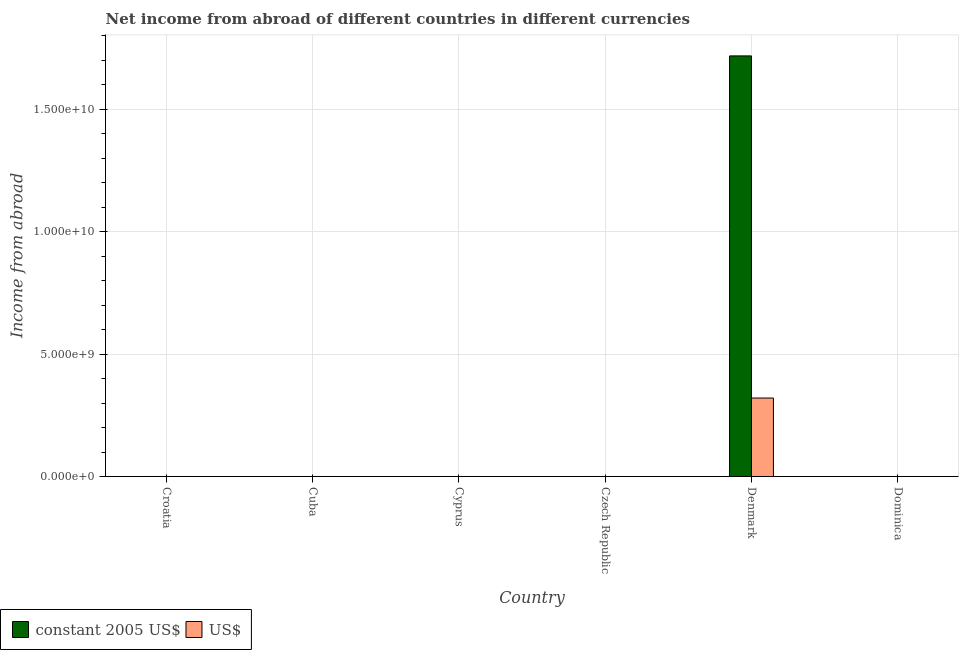What is the label of the 1st group of bars from the left?
Your answer should be compact. Croatia. What is the income from abroad in constant 2005 us$ in Denmark?
Ensure brevity in your answer.  1.72e+1. Across all countries, what is the maximum income from abroad in constant 2005 us$?
Your answer should be very brief. 1.72e+1. Across all countries, what is the minimum income from abroad in us$?
Give a very brief answer. 0. In which country was the income from abroad in constant 2005 us$ maximum?
Provide a short and direct response. Denmark. What is the total income from abroad in constant 2005 us$ in the graph?
Your response must be concise. 1.72e+1. What is the difference between the income from abroad in constant 2005 us$ in Denmark and the income from abroad in us$ in Croatia?
Provide a short and direct response. 1.72e+1. What is the average income from abroad in constant 2005 us$ per country?
Give a very brief answer. 2.86e+09. What is the difference between the income from abroad in us$ and income from abroad in constant 2005 us$ in Denmark?
Offer a very short reply. -1.40e+1. In how many countries, is the income from abroad in us$ greater than 7000000000 units?
Provide a short and direct response. 0. What is the difference between the highest and the lowest income from abroad in constant 2005 us$?
Provide a succinct answer. 1.72e+1. In how many countries, is the income from abroad in constant 2005 us$ greater than the average income from abroad in constant 2005 us$ taken over all countries?
Give a very brief answer. 1. Are the values on the major ticks of Y-axis written in scientific E-notation?
Your answer should be compact. Yes. Does the graph contain grids?
Give a very brief answer. Yes. How are the legend labels stacked?
Your answer should be very brief. Horizontal. What is the title of the graph?
Your answer should be compact. Net income from abroad of different countries in different currencies. Does "From human activities" appear as one of the legend labels in the graph?
Provide a succinct answer. No. What is the label or title of the Y-axis?
Keep it short and to the point. Income from abroad. What is the Income from abroad of constant 2005 US$ in Cuba?
Keep it short and to the point. 0. What is the Income from abroad in US$ in Cuba?
Offer a terse response. 0. What is the Income from abroad in constant 2005 US$ in Cyprus?
Give a very brief answer. 0. What is the Income from abroad of US$ in Cyprus?
Your response must be concise. 0. What is the Income from abroad of constant 2005 US$ in Czech Republic?
Keep it short and to the point. 0. What is the Income from abroad of US$ in Czech Republic?
Provide a succinct answer. 0. What is the Income from abroad in constant 2005 US$ in Denmark?
Offer a very short reply. 1.72e+1. What is the Income from abroad in US$ in Denmark?
Your answer should be very brief. 3.21e+09. Across all countries, what is the maximum Income from abroad of constant 2005 US$?
Give a very brief answer. 1.72e+1. Across all countries, what is the maximum Income from abroad of US$?
Give a very brief answer. 3.21e+09. Across all countries, what is the minimum Income from abroad in constant 2005 US$?
Provide a short and direct response. 0. Across all countries, what is the minimum Income from abroad in US$?
Make the answer very short. 0. What is the total Income from abroad of constant 2005 US$ in the graph?
Keep it short and to the point. 1.72e+1. What is the total Income from abroad in US$ in the graph?
Offer a very short reply. 3.21e+09. What is the average Income from abroad in constant 2005 US$ per country?
Provide a succinct answer. 2.86e+09. What is the average Income from abroad in US$ per country?
Give a very brief answer. 5.34e+08. What is the difference between the Income from abroad in constant 2005 US$ and Income from abroad in US$ in Denmark?
Give a very brief answer. 1.40e+1. What is the difference between the highest and the lowest Income from abroad in constant 2005 US$?
Keep it short and to the point. 1.72e+1. What is the difference between the highest and the lowest Income from abroad in US$?
Make the answer very short. 3.21e+09. 